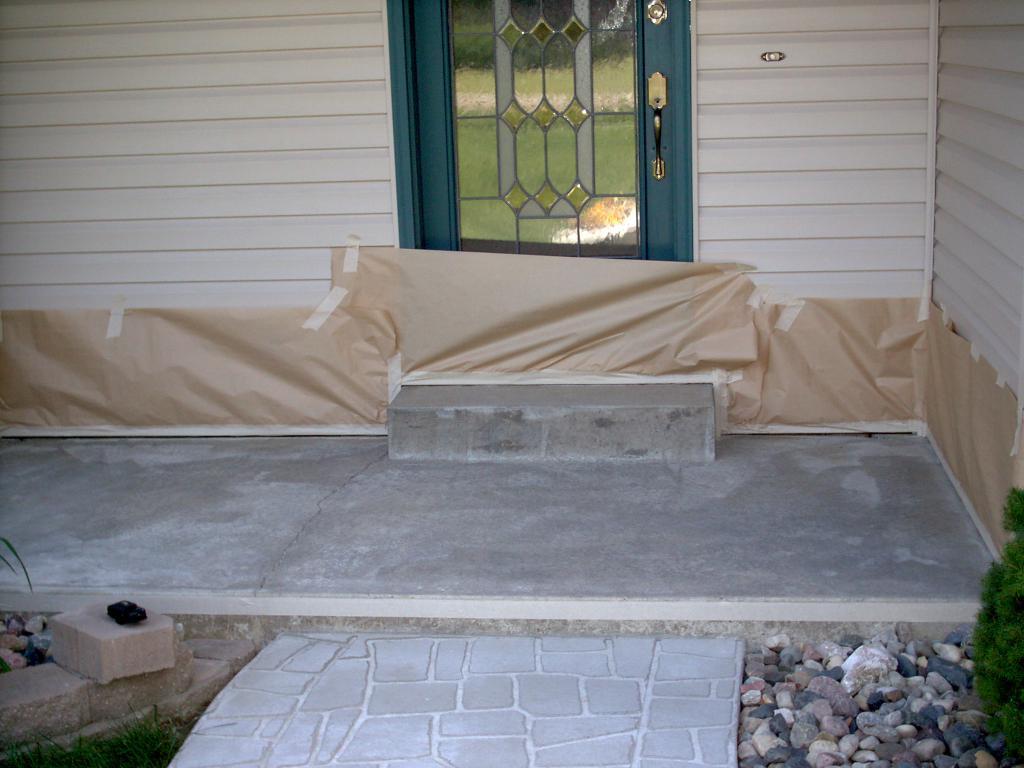In one or two sentences, can you explain what this image depicts? In this picture there is a door in the center of the image and there are pebbles at the bottom side of the image, it seems to be a house. 